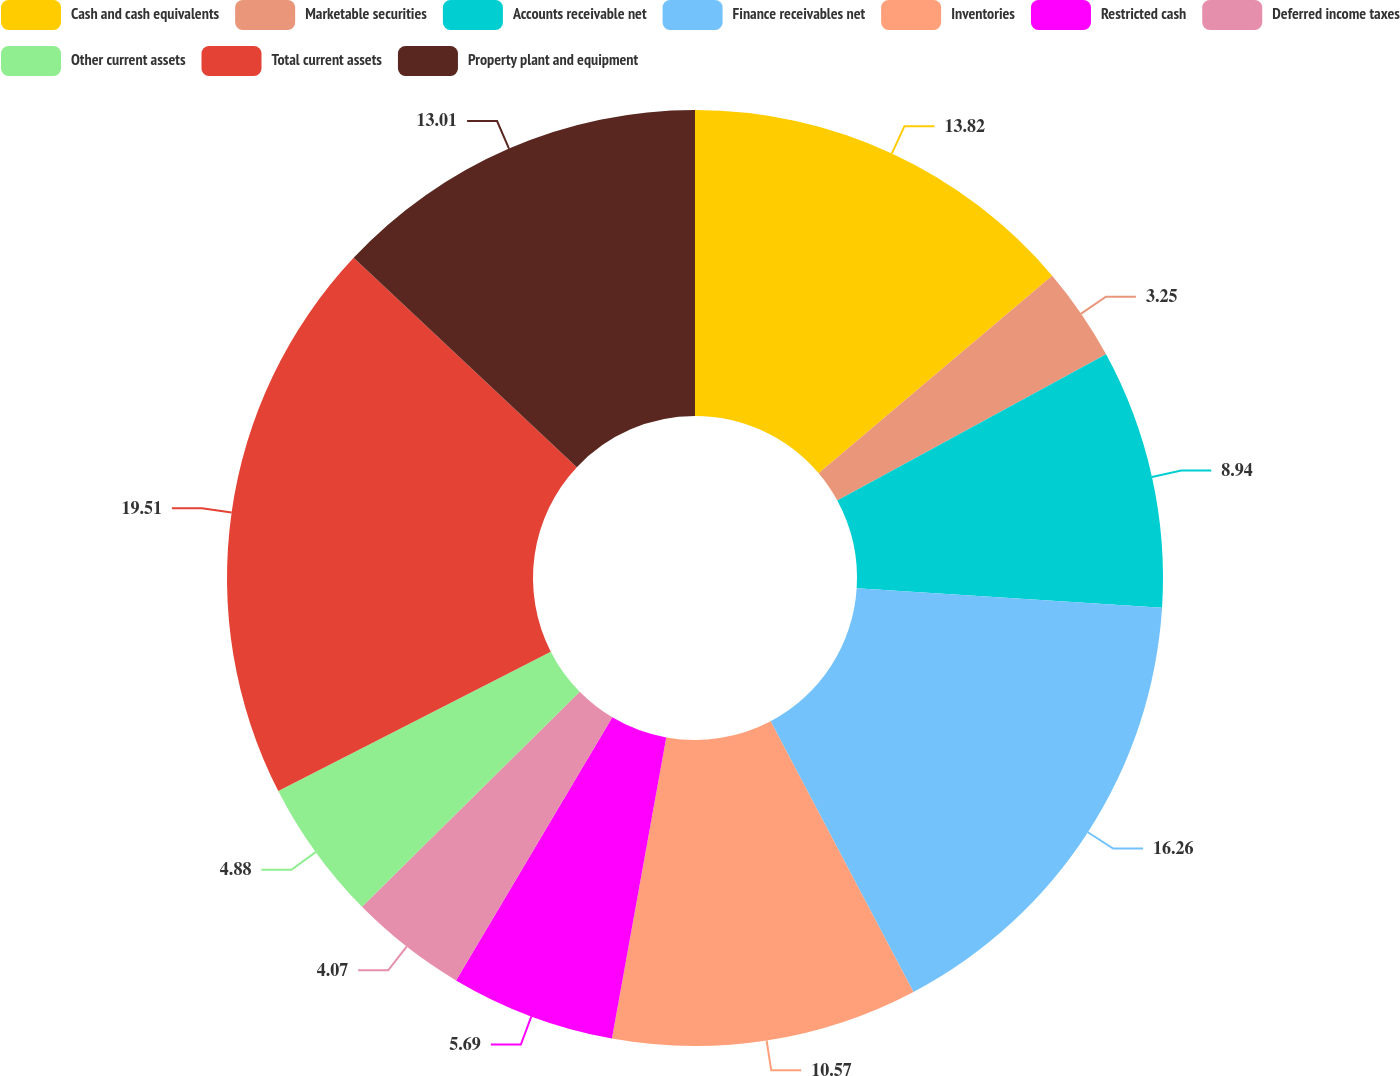Convert chart to OTSL. <chart><loc_0><loc_0><loc_500><loc_500><pie_chart><fcel>Cash and cash equivalents<fcel>Marketable securities<fcel>Accounts receivable net<fcel>Finance receivables net<fcel>Inventories<fcel>Restricted cash<fcel>Deferred income taxes<fcel>Other current assets<fcel>Total current assets<fcel>Property plant and equipment<nl><fcel>13.82%<fcel>3.25%<fcel>8.94%<fcel>16.26%<fcel>10.57%<fcel>5.69%<fcel>4.07%<fcel>4.88%<fcel>19.51%<fcel>13.01%<nl></chart> 